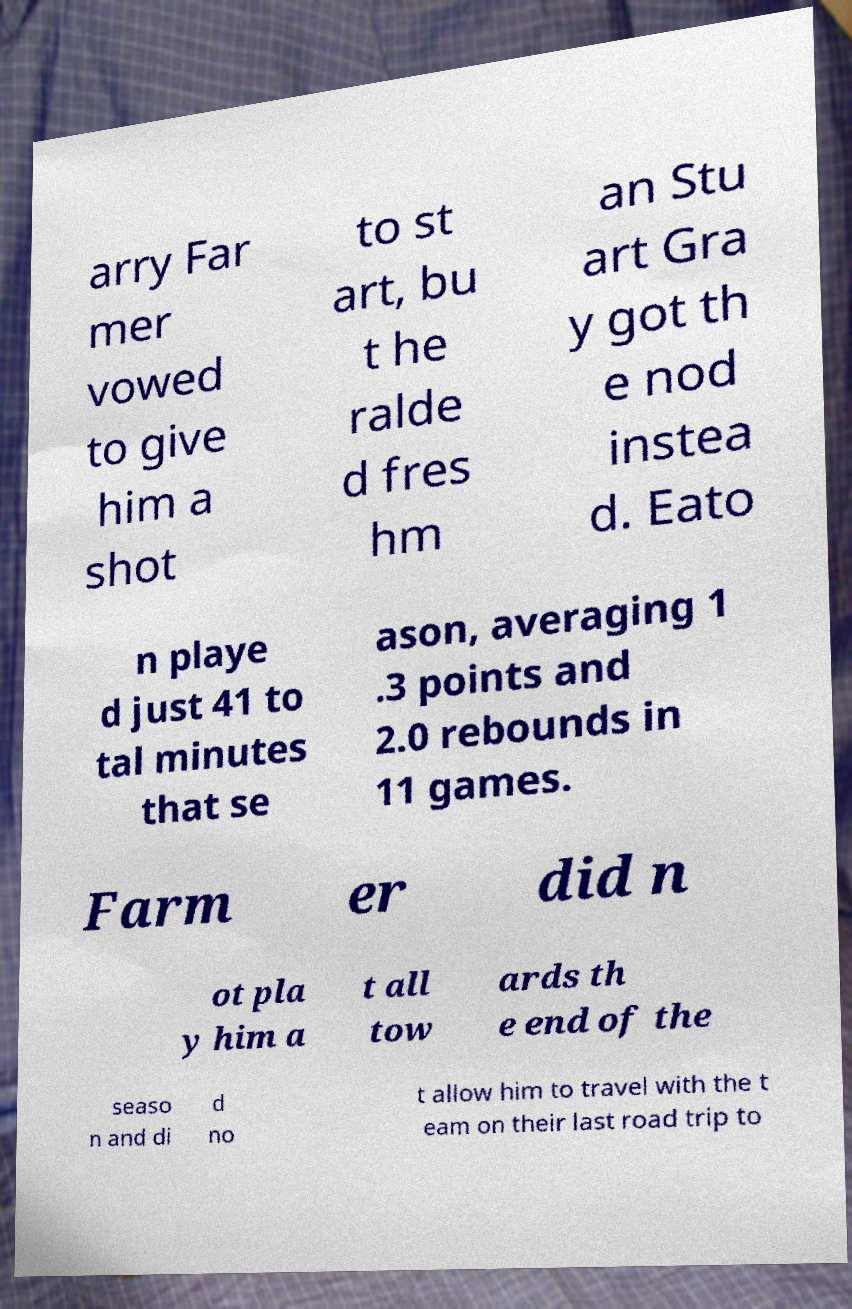Could you extract and type out the text from this image? arry Far mer vowed to give him a shot to st art, bu t he ralde d fres hm an Stu art Gra y got th e nod instea d. Eato n playe d just 41 to tal minutes that se ason, averaging 1 .3 points and 2.0 rebounds in 11 games. Farm er did n ot pla y him a t all tow ards th e end of the seaso n and di d no t allow him to travel with the t eam on their last road trip to 